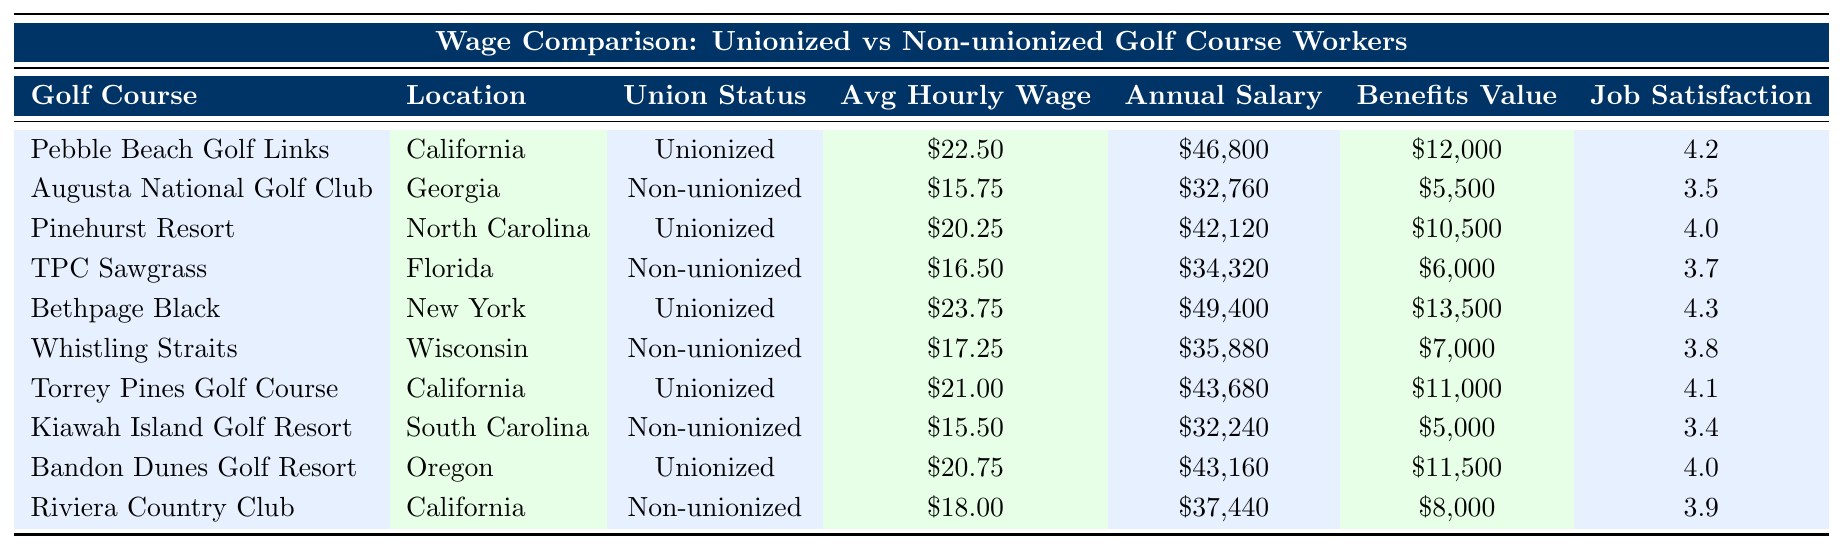What is the average hourly wage for unionized golf course workers? To find the average hourly wage for the unionized group, sum the average wages: $22.50 + $20.25 + $23.75 + $21.00 + $20.75 = $108.25. There are 5 unionized workers, so divide $108.25 by 5, resulting in an average of $21.65.
Answer: $21.65 Which golf course has the highest job satisfaction rating among non-unionized workers? The table shows the job satisfaction ratings for non-unionized workers. The ratings are: Augusta National Golf Club (3.5), TPC Sawgrass (3.7), Whistling Straits (3.8), Kiawah Island Golf Resort (3.4), and Riviera Country Club (3.9). The highest rating is 3.9 from Riviera Country Club.
Answer: Riviera Country Club What is the total annual salary for all unionized golf course workers? The annual salaries for the unionized workers are: $46,800 + $42,120 + $49,400 + $43,680 + $43,160 = $224,160. Therefore, the total annual salary for all unionized workers is $224,160.
Answer: $224,160 Is the average benefits package value higher for unionized or non-unionized workers? The average benefits for unionized workers are: $12,000 + $10,500 + $13,500 + $11,000 + $11,500 = $58,500 for 5 workers, averaging $11,700. The non-unionized benefits are: $5,500 + $6,000 + $7,000 + $5,000 + $8,000 = $31,500 for 5 workers, averaging $6,300. Since $11,700 is greater than $6,300, unionized workers have a higher average benefits package.
Answer: Yes What is the difference in average hourly wage between unionized and non-unionized workers? The average hourly wage for unionized workers is $21.65, and for non-unionized workers: $15.75 + $16.50 + $17.25 + $15.50 + $18.00 = $82.00, averaging $16.40. The difference is $21.65 - $16.40 = $5.25.
Answer: $5.25 Which unionized golf course has the lowest job satisfaction rating? The job satisfaction ratings for unionized courses are: Pebble Beach Golf Links (4.2), Pinehurst Resort (4.0), Bethpage Black (4.3), Torrey Pines Golf Course (4.1), and Bandon Dunes Golf Resort (4.0). The lowest rating is 4.0 from both Pinehurst Resort and Bandon Dunes Golf Resort.
Answer: Pinehurst Resort and Bandon Dunes Golf Resort How much higher is the average annual salary for unionized workers compared to non-unionized workers? The average annual salary for unionized workers, $224,160 divided by 5, is $44,832. For non-unionized workers, $32,760 + $34,320 + $35,880 + $32,240 + $37,440 = $172,640 divided by 5 is $34,528. The difference is $44,832 - $34,528 = $10,304.
Answer: $10,304 How many golf courses are listed in the table? By counting the data entries, there are a total of 10 golf courses listed in the table.
Answer: 10 